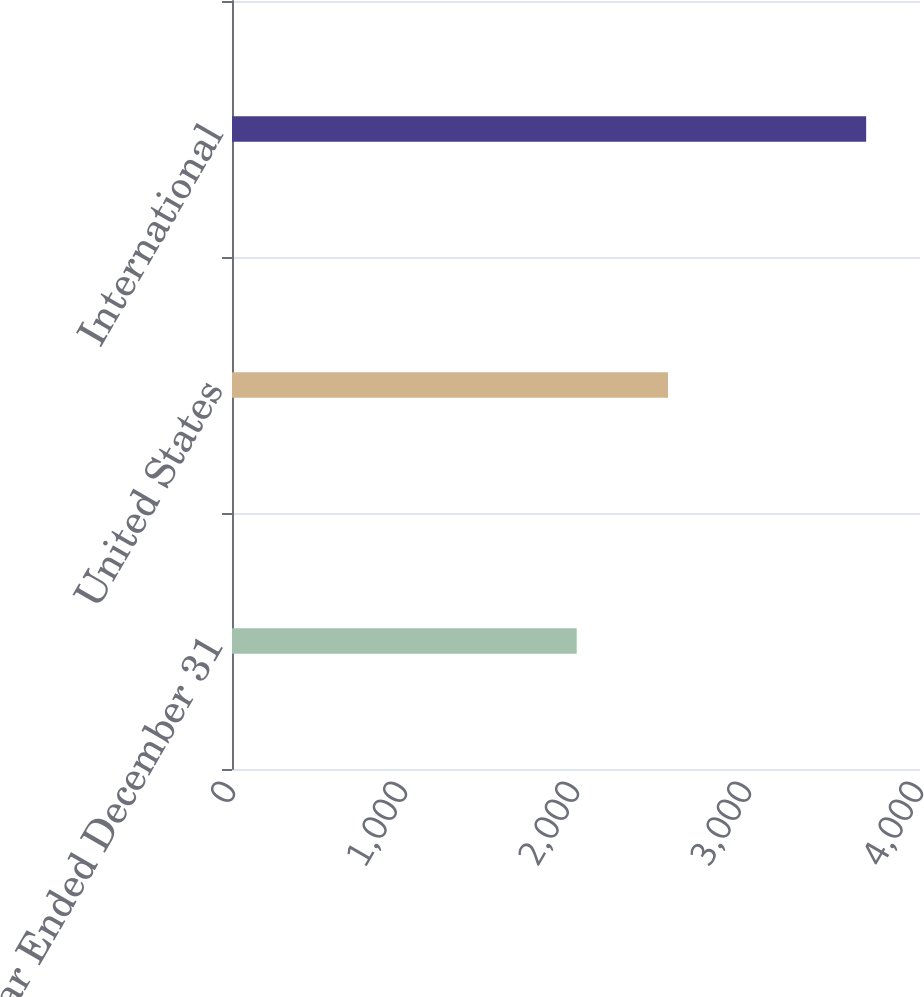Convert chart to OTSL. <chart><loc_0><loc_0><loc_500><loc_500><bar_chart><fcel>Year Ended December 31<fcel>United States<fcel>International<nl><fcel>2004<fcel>2535<fcel>3687<nl></chart> 